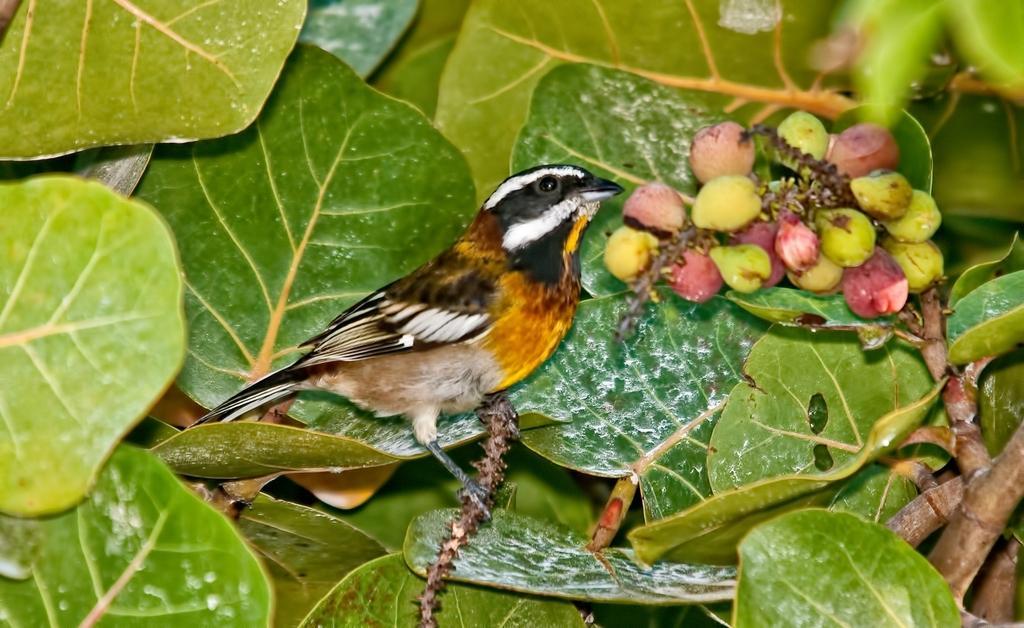In one or two sentences, can you explain what this image depicts? In the center of the image, we can see a bird on the stem and in the background, there are leaves and we can see fruits. 